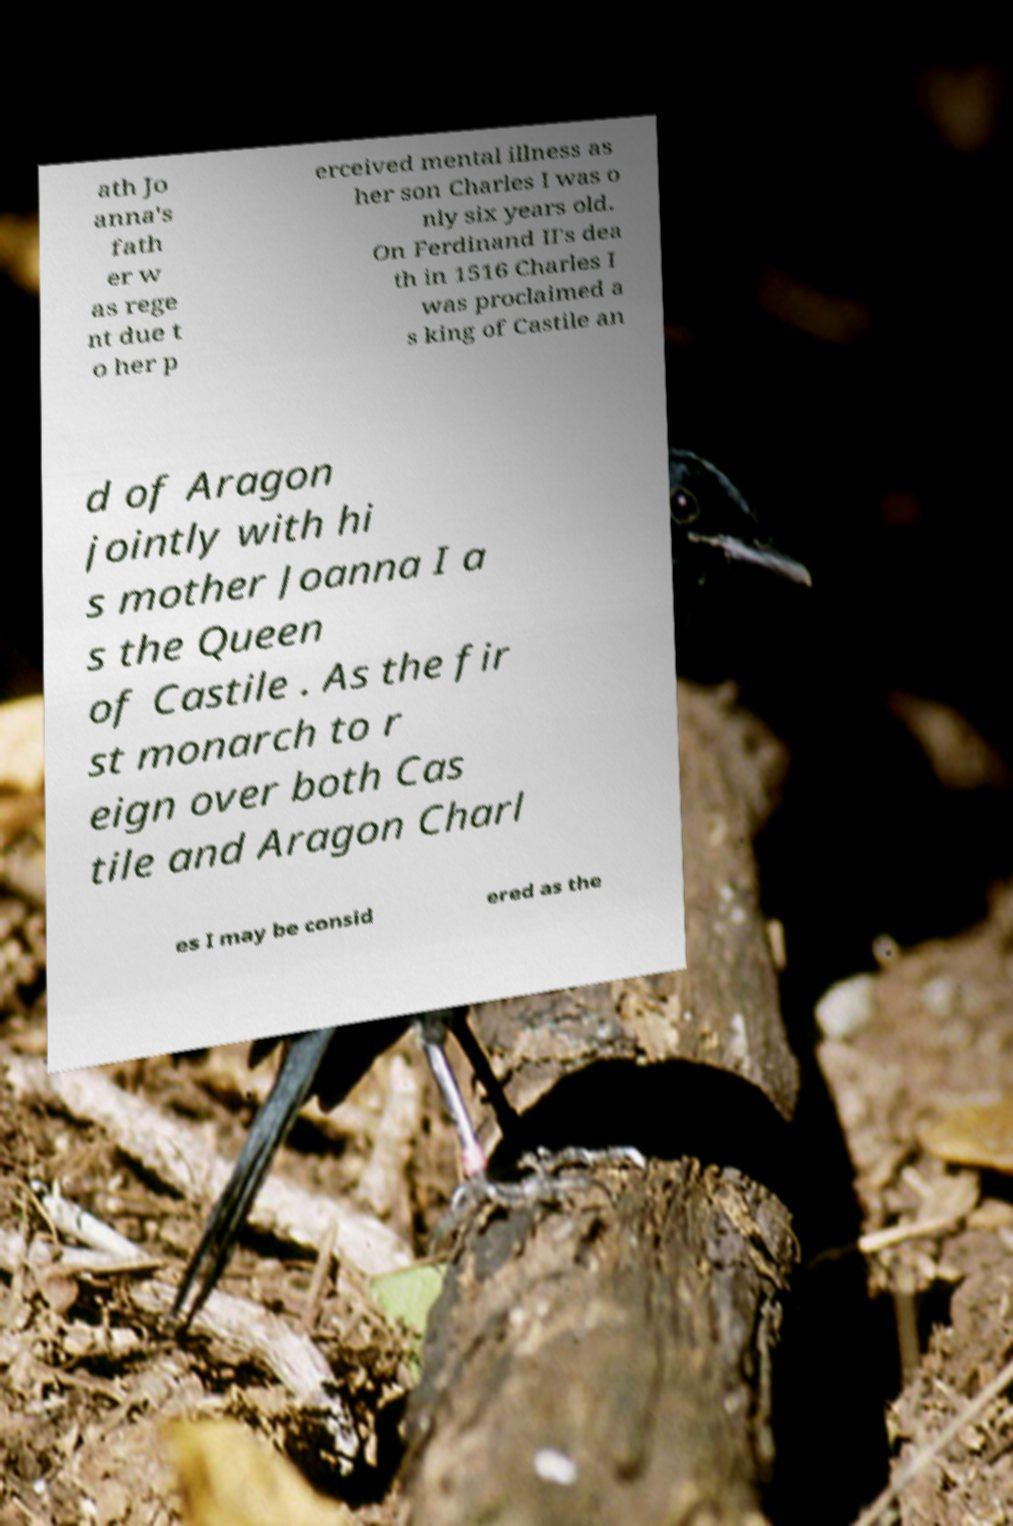There's text embedded in this image that I need extracted. Can you transcribe it verbatim? ath Jo anna's fath er w as rege nt due t o her p erceived mental illness as her son Charles I was o nly six years old. On Ferdinand II's dea th in 1516 Charles I was proclaimed a s king of Castile an d of Aragon jointly with hi s mother Joanna I a s the Queen of Castile . As the fir st monarch to r eign over both Cas tile and Aragon Charl es I may be consid ered as the 